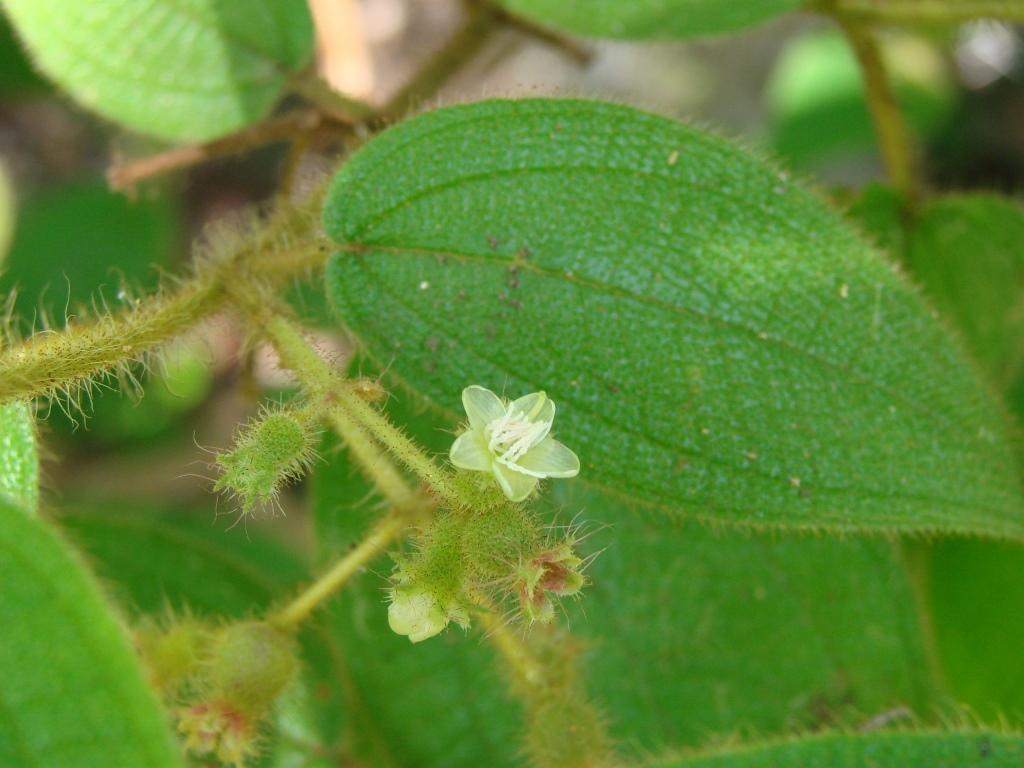How would you summarize this image in a sentence or two? In this image I can see there are some leaves and flowers to the stem of a plant. 